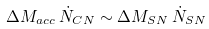<formula> <loc_0><loc_0><loc_500><loc_500>\Delta M _ { a c c } \, \dot { N } _ { C N } \sim \Delta M _ { S N } \, \dot { N } _ { S N }</formula> 